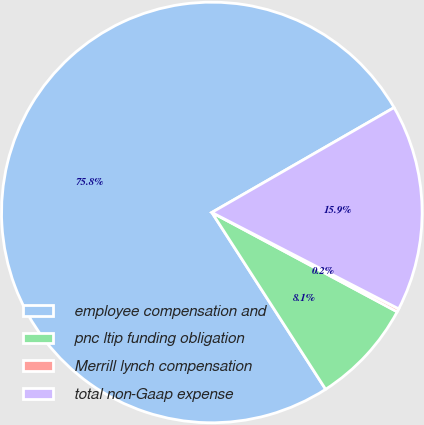Convert chart to OTSL. <chart><loc_0><loc_0><loc_500><loc_500><pie_chart><fcel>employee compensation and<fcel>pnc ltip funding obligation<fcel>Merrill lynch compensation<fcel>total non-Gaap expense<nl><fcel>75.79%<fcel>8.07%<fcel>0.25%<fcel>15.89%<nl></chart> 